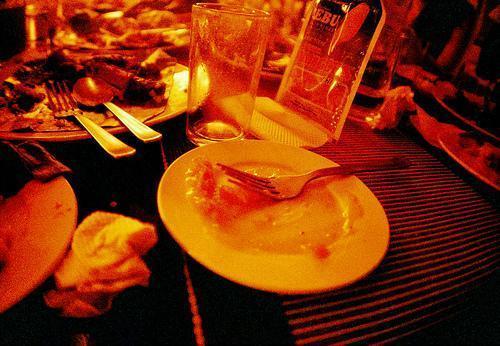How many utensils are visible?
Give a very brief answer. 3. How many prongs are on each fork?
Give a very brief answer. 4. How many utensils are on the empty plate?
Give a very brief answer. 1. 